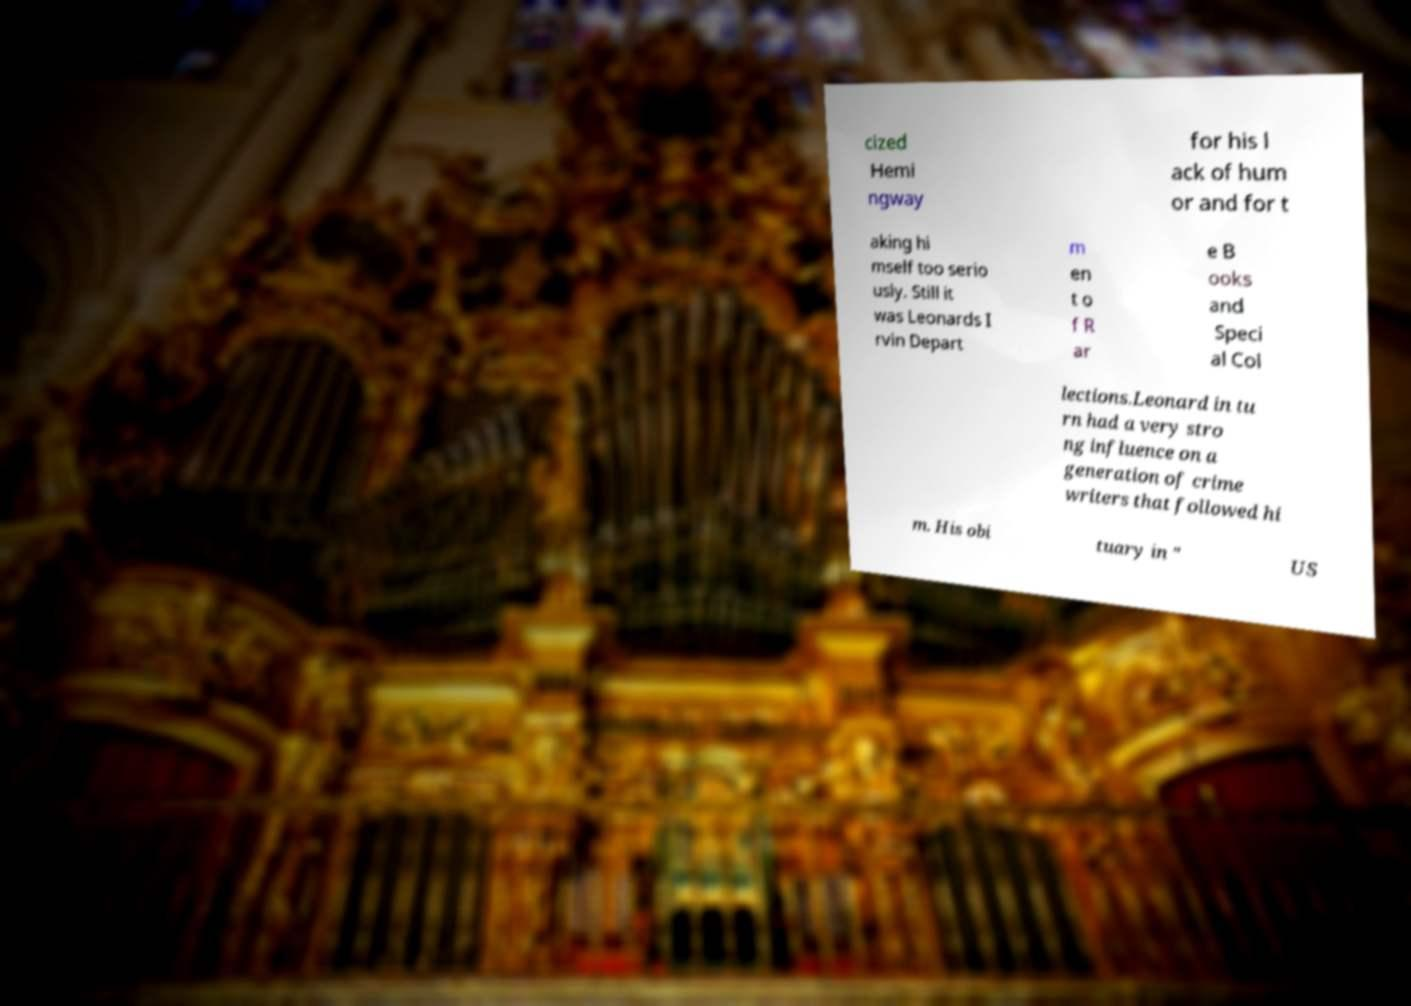What messages or text are displayed in this image? I need them in a readable, typed format. cized Hemi ngway for his l ack of hum or and for t aking hi mself too serio usly. Still it was Leonards I rvin Depart m en t o f R ar e B ooks and Speci al Col lections.Leonard in tu rn had a very stro ng influence on a generation of crime writers that followed hi m. His obi tuary in " US 